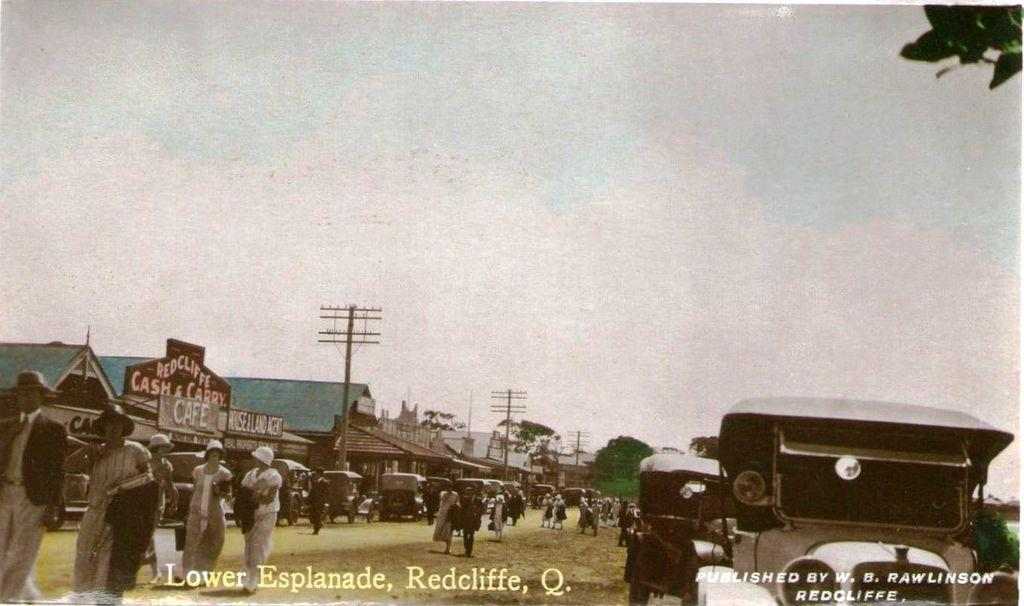What can be seen in the sky in the image? The sky is visible in the image. What type of structures are present in the image? There are electric poles and buildings in the image. What type of transportation is present in the image? Motor vehicles are present in the image. What type of natural elements are present in the image? Trees are visible in the image. Are there any people in the image? Yes, there are persons on the ground in the image. Where is the mailbox located in the image? There is no mailbox present in the image. What type of bell can be heard ringing in the image? There is no bell present in the image, and therefore no sound can be heard. 